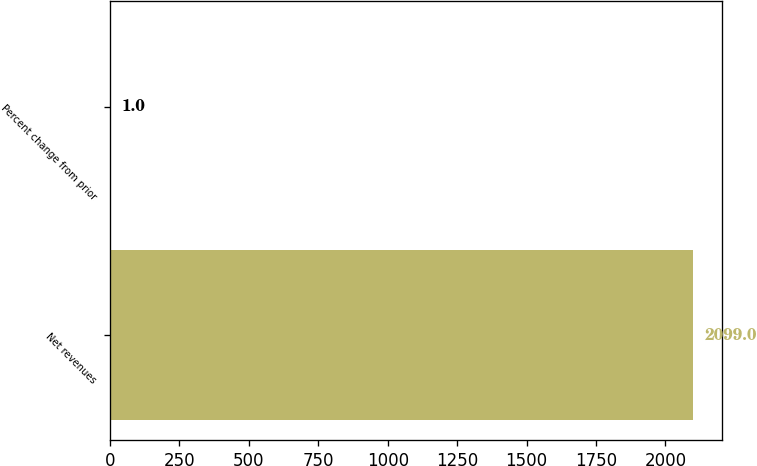<chart> <loc_0><loc_0><loc_500><loc_500><bar_chart><fcel>Net revenues<fcel>Percent change from prior<nl><fcel>2099<fcel>1<nl></chart> 